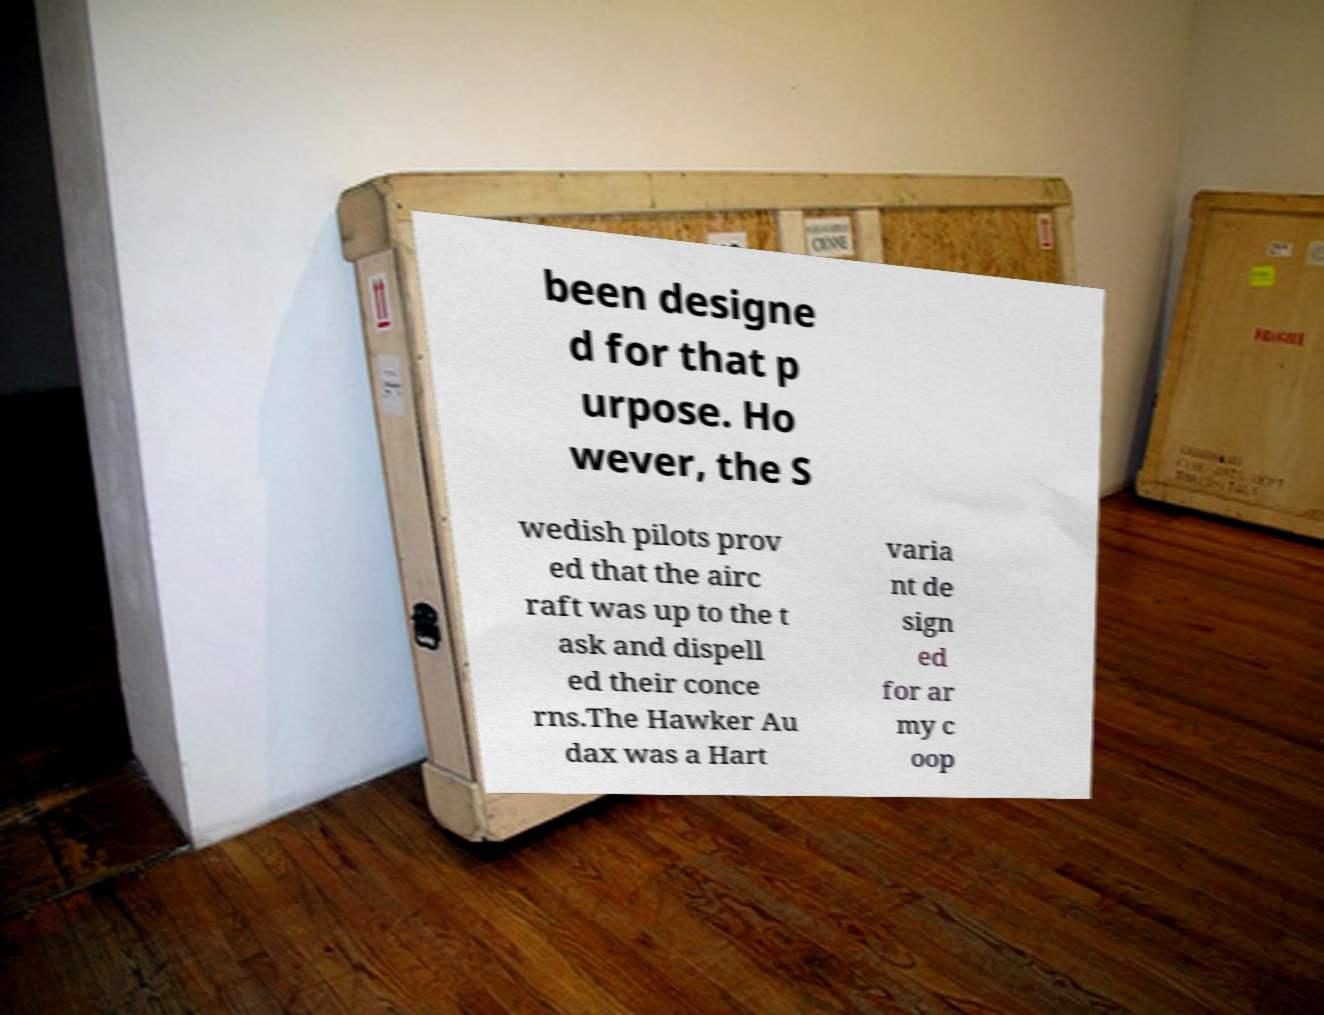For documentation purposes, I need the text within this image transcribed. Could you provide that? been designe d for that p urpose. Ho wever, the S wedish pilots prov ed that the airc raft was up to the t ask and dispell ed their conce rns.The Hawker Au dax was a Hart varia nt de sign ed for ar my c oop 